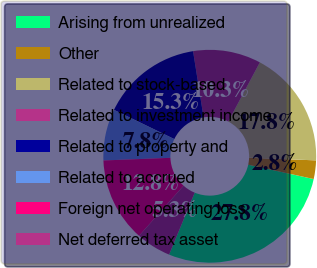Convert chart. <chart><loc_0><loc_0><loc_500><loc_500><pie_chart><fcel>Arising from unrealized<fcel>Other<fcel>Related to stock-based<fcel>Related to investment income<fcel>Related to property and<fcel>Related to accrued<fcel>Foreign net operating loss<fcel>Net deferred tax asset<nl><fcel>27.8%<fcel>2.82%<fcel>17.81%<fcel>10.31%<fcel>15.31%<fcel>7.81%<fcel>12.81%<fcel>5.32%<nl></chart> 